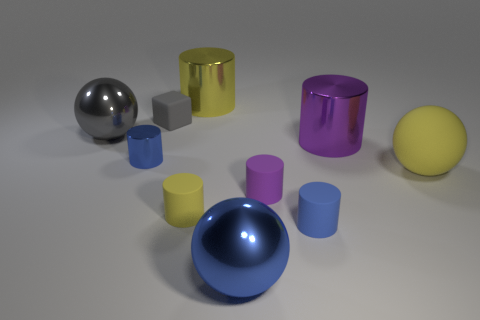How many other things are there of the same color as the small cube?
Offer a terse response. 1. There is a sphere to the left of the small blue cylinder to the left of the small purple cylinder; what number of small yellow cylinders are behind it?
Offer a terse response. 0. How many cylinders are small objects or small blue rubber things?
Give a very brief answer. 4. The large metallic object behind the small thing behind the blue object that is behind the large yellow ball is what color?
Provide a succinct answer. Yellow. What number of other things are there of the same size as the blue rubber object?
Offer a very short reply. 4. Are there any other things that have the same shape as the gray matte thing?
Provide a short and direct response. No. There is a large rubber object that is the same shape as the large blue shiny thing; what color is it?
Make the answer very short. Yellow. There is a big object that is made of the same material as the tiny block; what color is it?
Your answer should be very brief. Yellow. Are there an equal number of purple matte things behind the yellow rubber cylinder and gray blocks?
Your answer should be very brief. Yes. There is a gray thing that is behind the gray metallic ball; does it have the same size as the tiny metallic object?
Keep it short and to the point. Yes. 